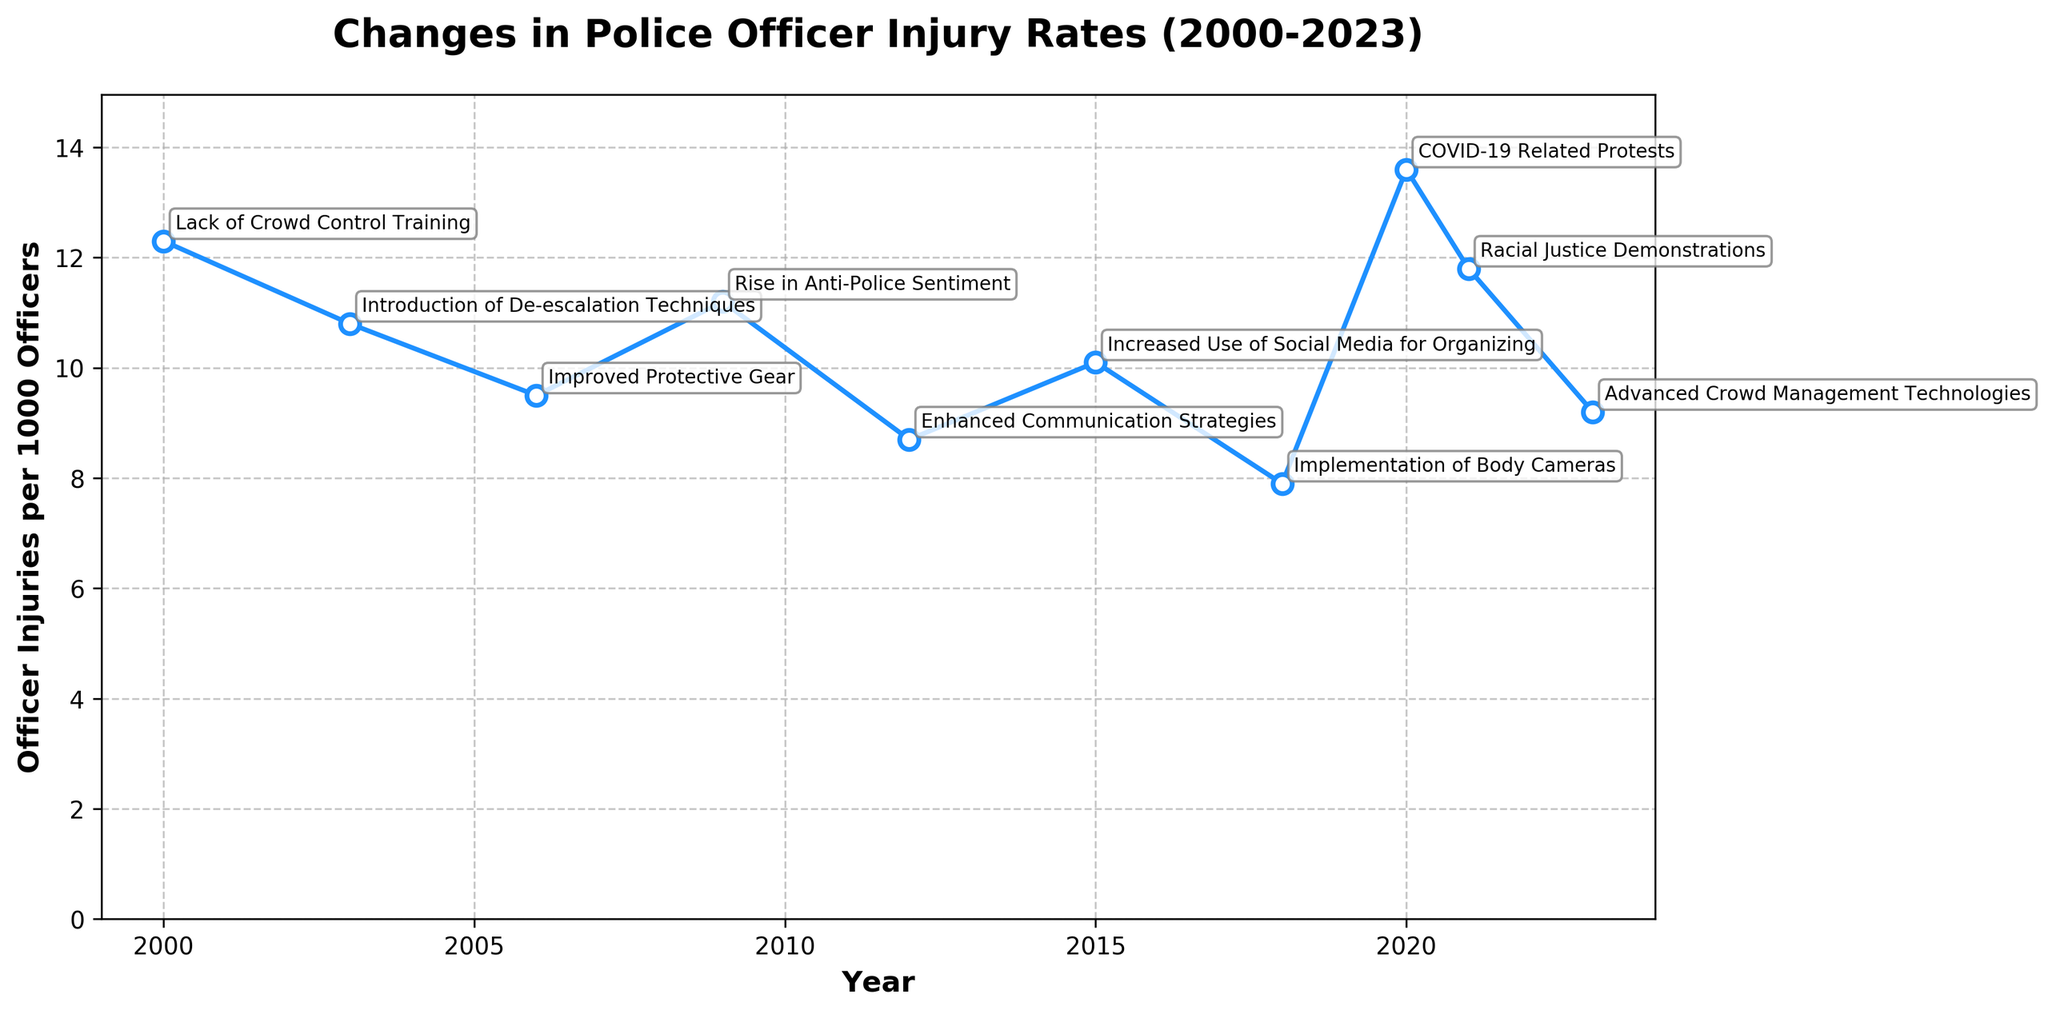Which year had the highest officer injury rate? First, scan the y-axis to determine the injury rates. Second, identify the peak point on the plot around the highest value and note its corresponding year. The highest rate on the chart is 13.6 which occurred in 2020.
Answer: 2020 What was the injury rate in 2015? Locate the year 2015 on the x-axis and then trace up to the point on the y-axis that corresponds to it. The injury rate for 2015 is at 10.1.
Answer: 10.1 How does the injury rate in 2009 compare to that in 2018? Locate both 2009 and 2018 on the x-axis. Observe the corresponding values on the y-axis. The rate in 2009 is 11.2, and the rate in 2018 is 7.9. Compare the two numbers to find that 2009 is higher than 2018.
Answer: 2009 is higher By how much did the injury rate change from 2000 to 2006? Find the injury rates for 2000 (12.3) and 2006 (9.5). Calculate the difference by subtracting the 2006 number from the 2000 number, 12.3 - 9.5. This gives the change.
Answer: 2.8 What is the overall trend in officer injury rates from 2000 to 2023? Observe the line plot from the start year 2000 to the end year 2023. Notice the general direction of the line. The initial rate is 12.3 in 2000, ending at 9.2 in 2023 with several fluctuations in between. The overall trend shows a general decrease over time.
Answer: General decrease Which year saw the largest drop in officer injury rates compared to the previous year? Evaluate the differences between consecutive years by examining the plot points and labels closely. The largest drop occurred from 2020 (13.6) to 2021 (11.8). Calculate the difference to confirm: 13.6 - 11.8 = 1.8, making it the largest single-year drop.
Answer: 2021 What was the major contributing factor in 2018? Find the year 2018 on the plot and look at the label associated with it. The major contributing factor for 2018 was "Implementation of Body Cameras".
Answer: Implementation of Body Cameras If you average the injury rates for the years 2012, 2015, and 2018, what do you get? Find the injury rates for 2012 (8.7), 2015 (10.1), and 2018 (7.9). Add these rates together: 8.7 + 10.1 + 7.9 = 26.7. Divide by 3 to find the average: 26.7 / 3 = 8.9.
Answer: 8.9 What is the median injury rate of the dataset? First, list the injury rates in ascending order: 7.9, 8.7, 9.2, 9.5, 10.1, 10.8, 11.2, 11.8, 12.3, 13.6. The median value is the middle number. Since there are 10 values, the median is the average of the 5th and 6th values: (10.1 + 10.8) / 2 = 10.45.
Answer: 10.45 